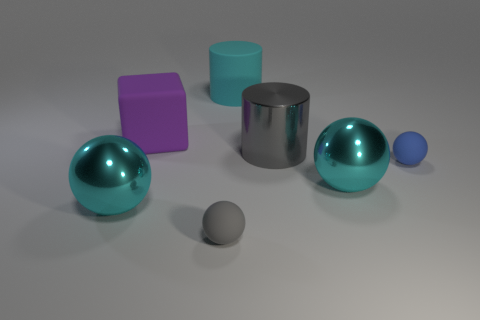What is the size of the rubber object that is in front of the gray metallic thing and to the left of the large cyan cylinder?
Offer a terse response. Small. What is the color of the big block that is made of the same material as the big cyan cylinder?
Make the answer very short. Purple. How many gray things have the same material as the blue ball?
Give a very brief answer. 1. Are there the same number of big purple matte things right of the cyan cylinder and small blue things that are in front of the gray metallic object?
Offer a terse response. No. Does the gray rubber thing have the same shape as the tiny blue rubber object in front of the large matte cylinder?
Ensure brevity in your answer.  Yes. There is a small sphere that is the same color as the metal cylinder; what material is it?
Your answer should be compact. Rubber. Are there any other things that have the same shape as the purple rubber object?
Your response must be concise. No. Is the big gray thing made of the same material as the cyan sphere left of the tiny gray matte thing?
Your answer should be compact. Yes. There is a big block behind the ball that is in front of the large cyan ball that is to the left of the large purple matte object; what color is it?
Give a very brief answer. Purple. There is a matte cylinder; is it the same color as the shiny sphere that is on the left side of the gray metal object?
Give a very brief answer. Yes. 